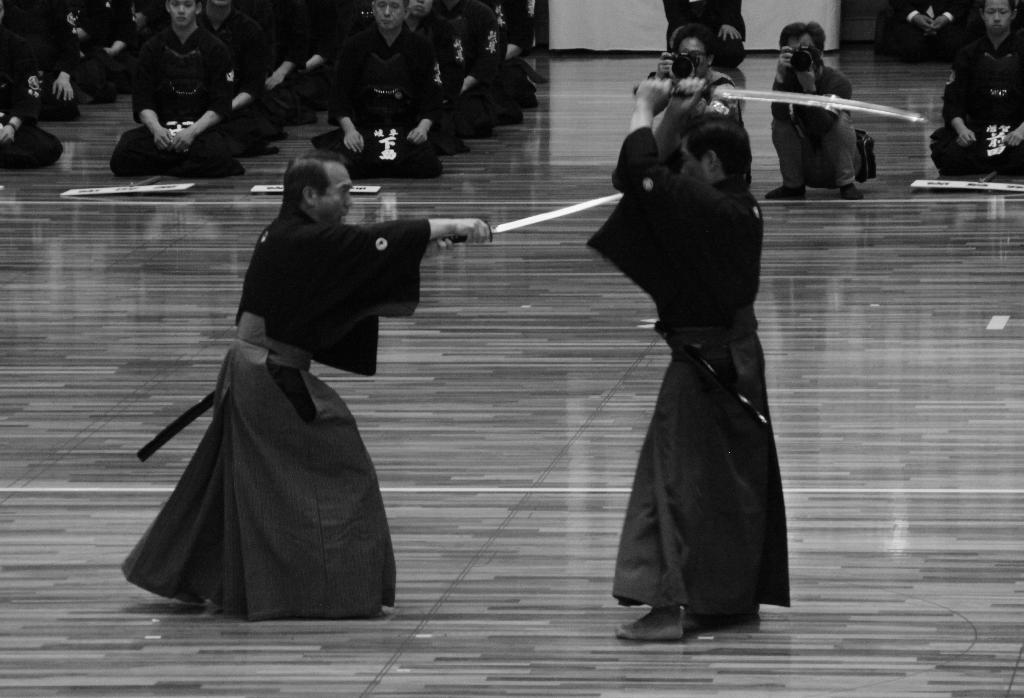What are the two people in the image holding? The two people in the image are holding swords. Can you see a monkey climbing the arch in the image? There is no arch or monkey present in the image. 